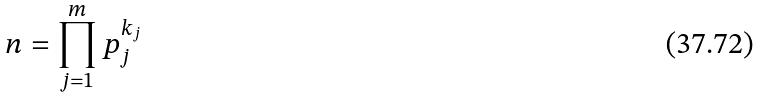Convert formula to latex. <formula><loc_0><loc_0><loc_500><loc_500>n = \prod _ { j = 1 } ^ { m } p _ { j } ^ { k _ { j } }</formula> 